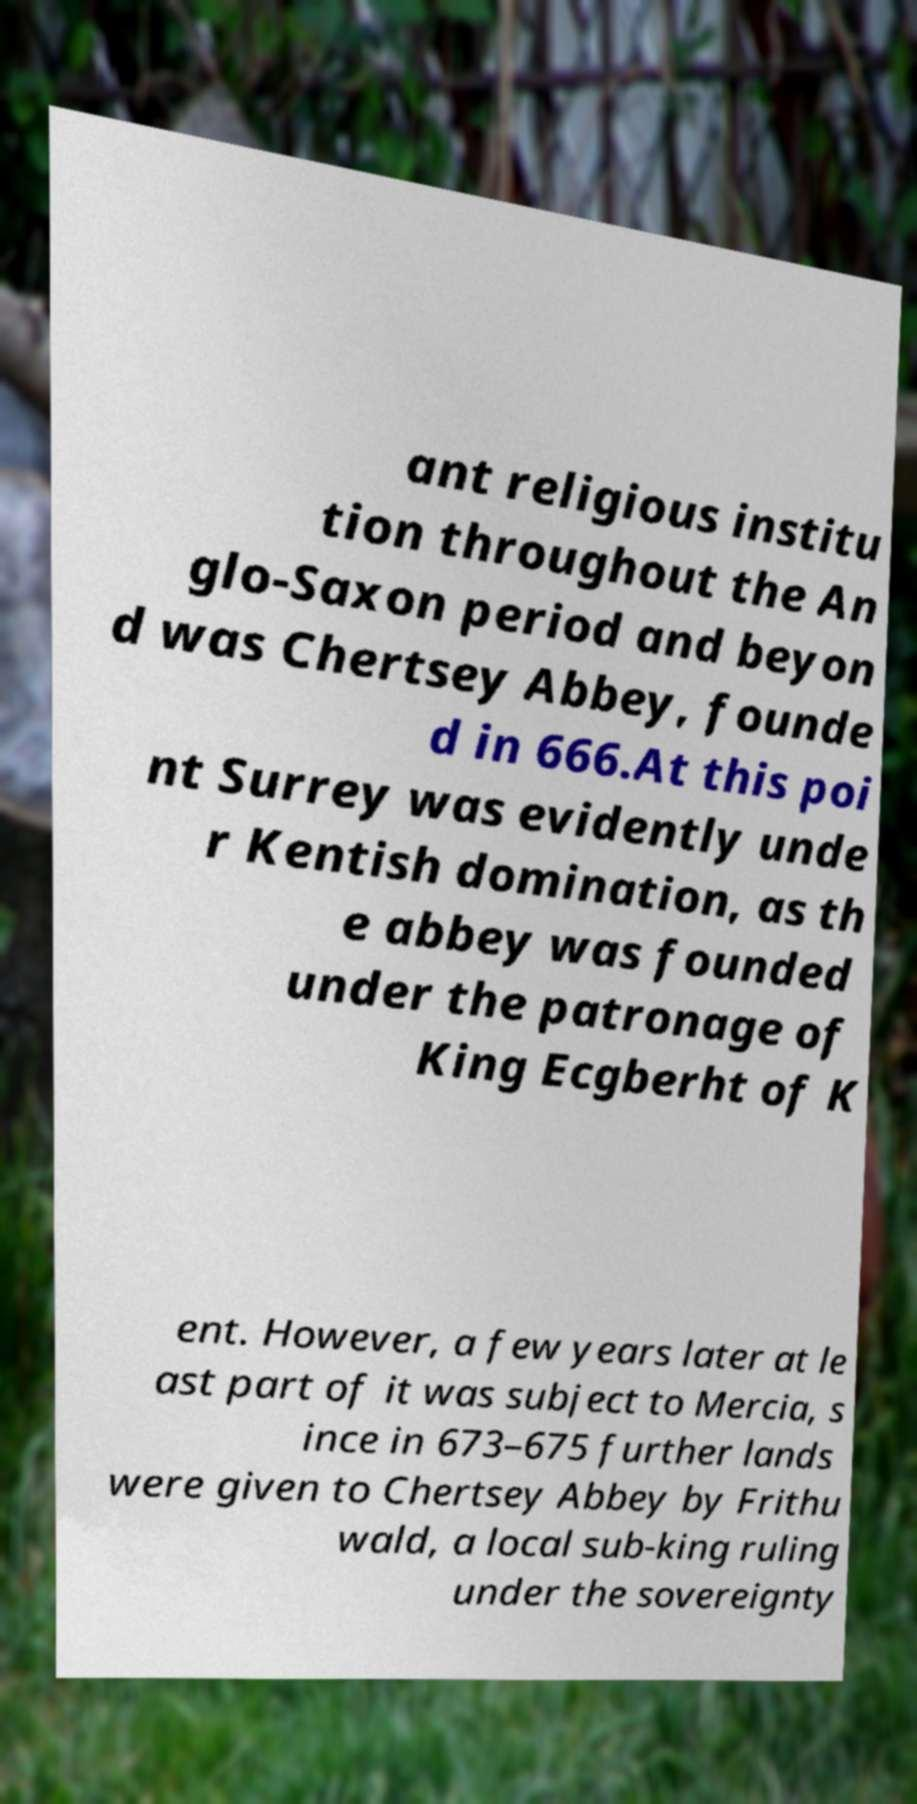Can you accurately transcribe the text from the provided image for me? ant religious institu tion throughout the An glo-Saxon period and beyon d was Chertsey Abbey, founde d in 666.At this poi nt Surrey was evidently unde r Kentish domination, as th e abbey was founded under the patronage of King Ecgberht of K ent. However, a few years later at le ast part of it was subject to Mercia, s ince in 673–675 further lands were given to Chertsey Abbey by Frithu wald, a local sub-king ruling under the sovereignty 